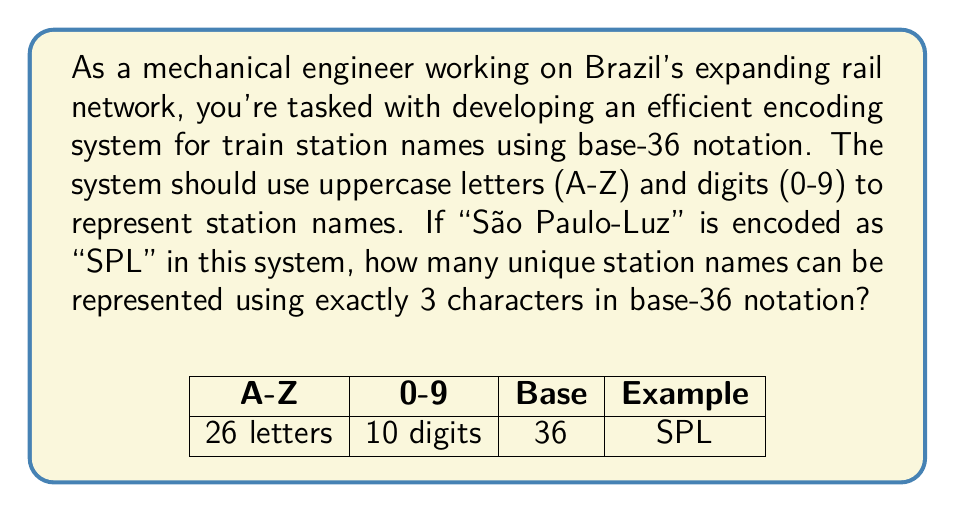Teach me how to tackle this problem. Let's approach this step-by-step:

1) In base-36 notation, we have 36 possible characters for each position:
   - 26 uppercase letters (A-Z)
   - 10 digits (0-9)

2) We are using exactly 3 characters for each station name.

3) For each character position, we have 36 choices.

4) Using the multiplication principle, the total number of possible combinations is:

   $$ 36 \times 36 \times 36 = 36^3 $$

5) Let's calculate this:

   $$ 36^3 = 46,656 $$

Therefore, using 3 characters in base-36 notation, we can represent 46,656 unique station names.

This system is efficient because:
- It's compact (only 3 characters)
- It allows for a large number of unique names
- It's easily readable and typeable (using standard keyboard characters)

For a growing rail network in Brazil, this provides ample room for expansion while keeping codes short and manageable.
Answer: 46,656 